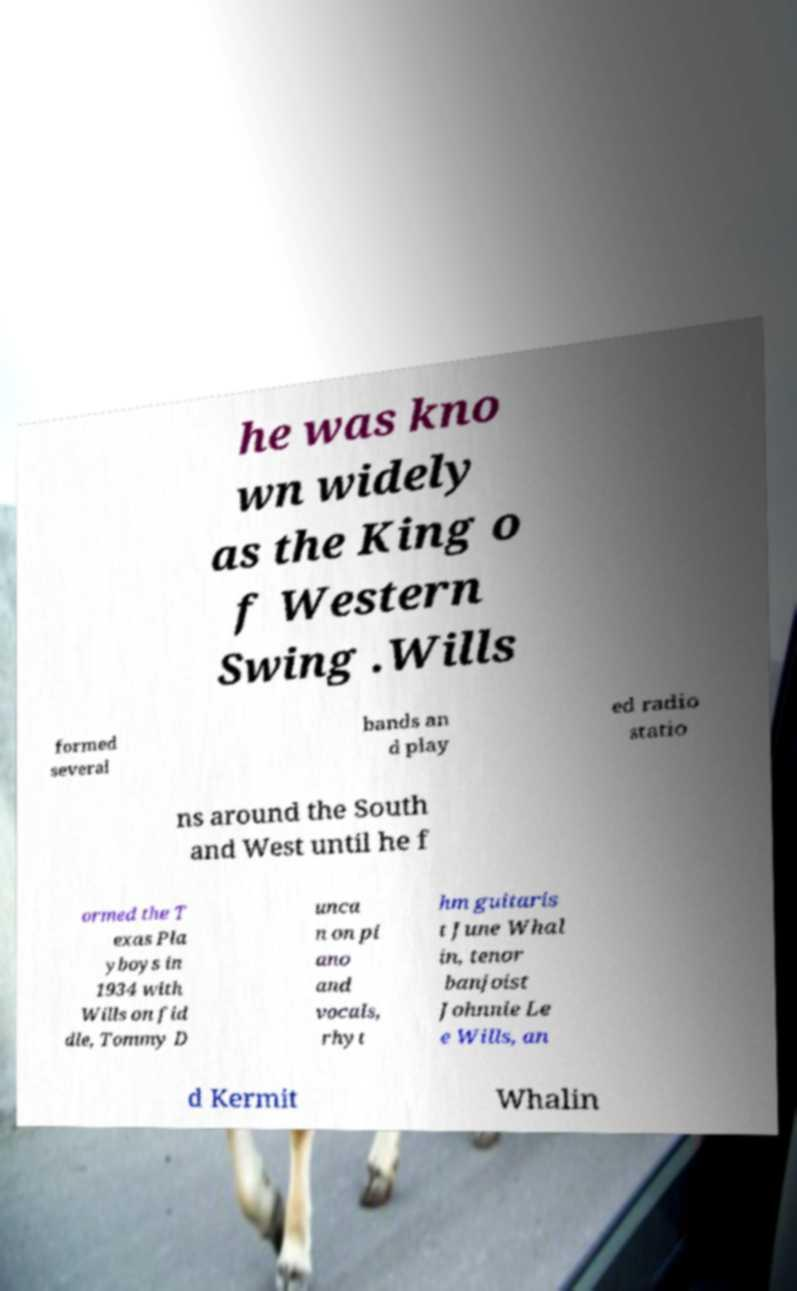For documentation purposes, I need the text within this image transcribed. Could you provide that? he was kno wn widely as the King o f Western Swing .Wills formed several bands an d play ed radio statio ns around the South and West until he f ormed the T exas Pla yboys in 1934 with Wills on fid dle, Tommy D unca n on pi ano and vocals, rhyt hm guitaris t June Whal in, tenor banjoist Johnnie Le e Wills, an d Kermit Whalin 